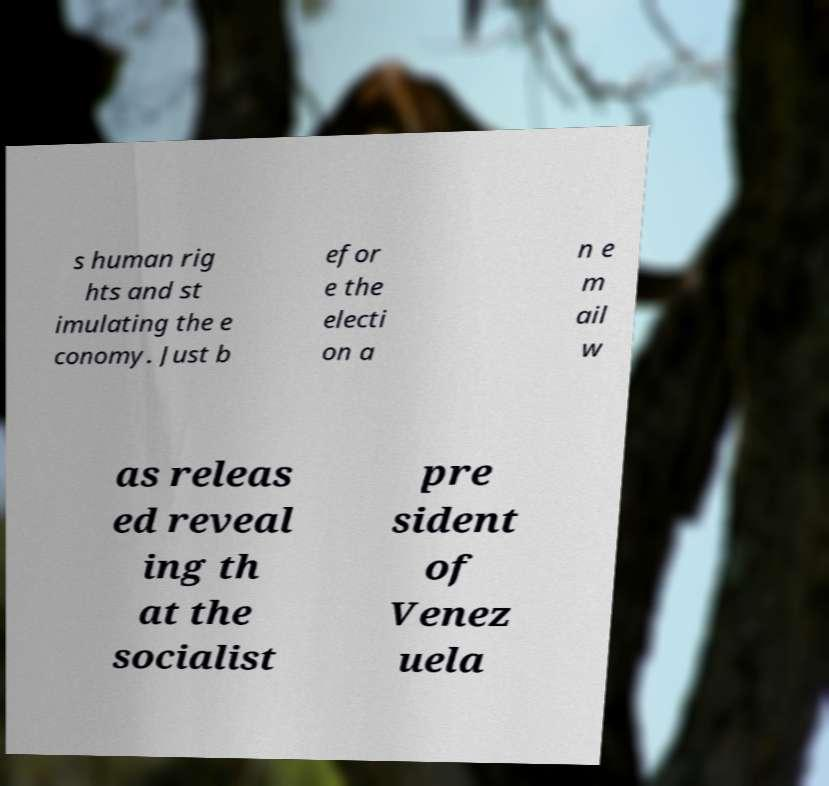Could you assist in decoding the text presented in this image and type it out clearly? s human rig hts and st imulating the e conomy. Just b efor e the electi on a n e m ail w as releas ed reveal ing th at the socialist pre sident of Venez uela 